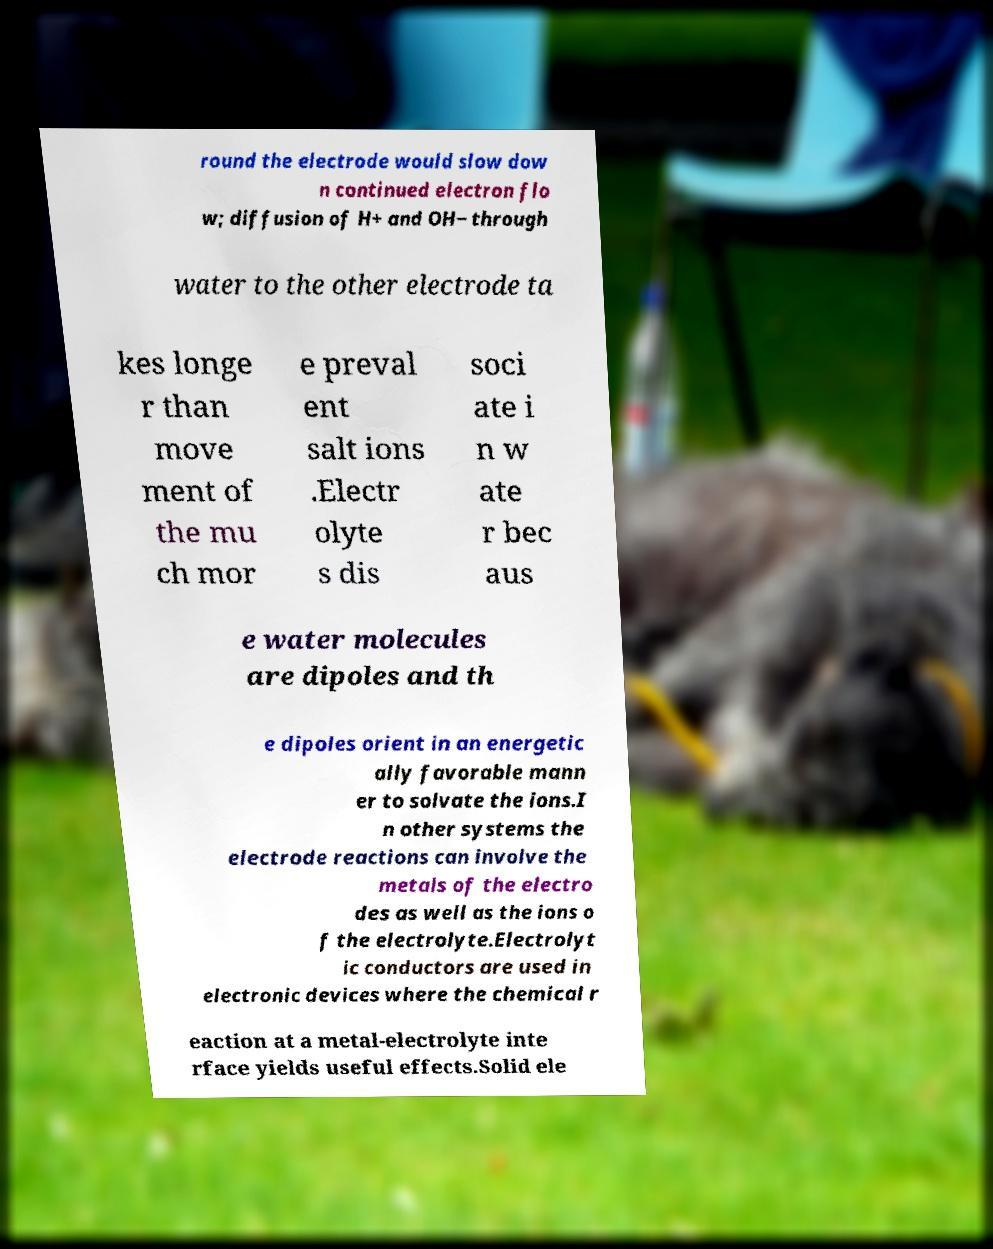Could you assist in decoding the text presented in this image and type it out clearly? round the electrode would slow dow n continued electron flo w; diffusion of H+ and OH− through water to the other electrode ta kes longe r than move ment of the mu ch mor e preval ent salt ions .Electr olyte s dis soci ate i n w ate r bec aus e water molecules are dipoles and th e dipoles orient in an energetic ally favorable mann er to solvate the ions.I n other systems the electrode reactions can involve the metals of the electro des as well as the ions o f the electrolyte.Electrolyt ic conductors are used in electronic devices where the chemical r eaction at a metal-electrolyte inte rface yields useful effects.Solid ele 